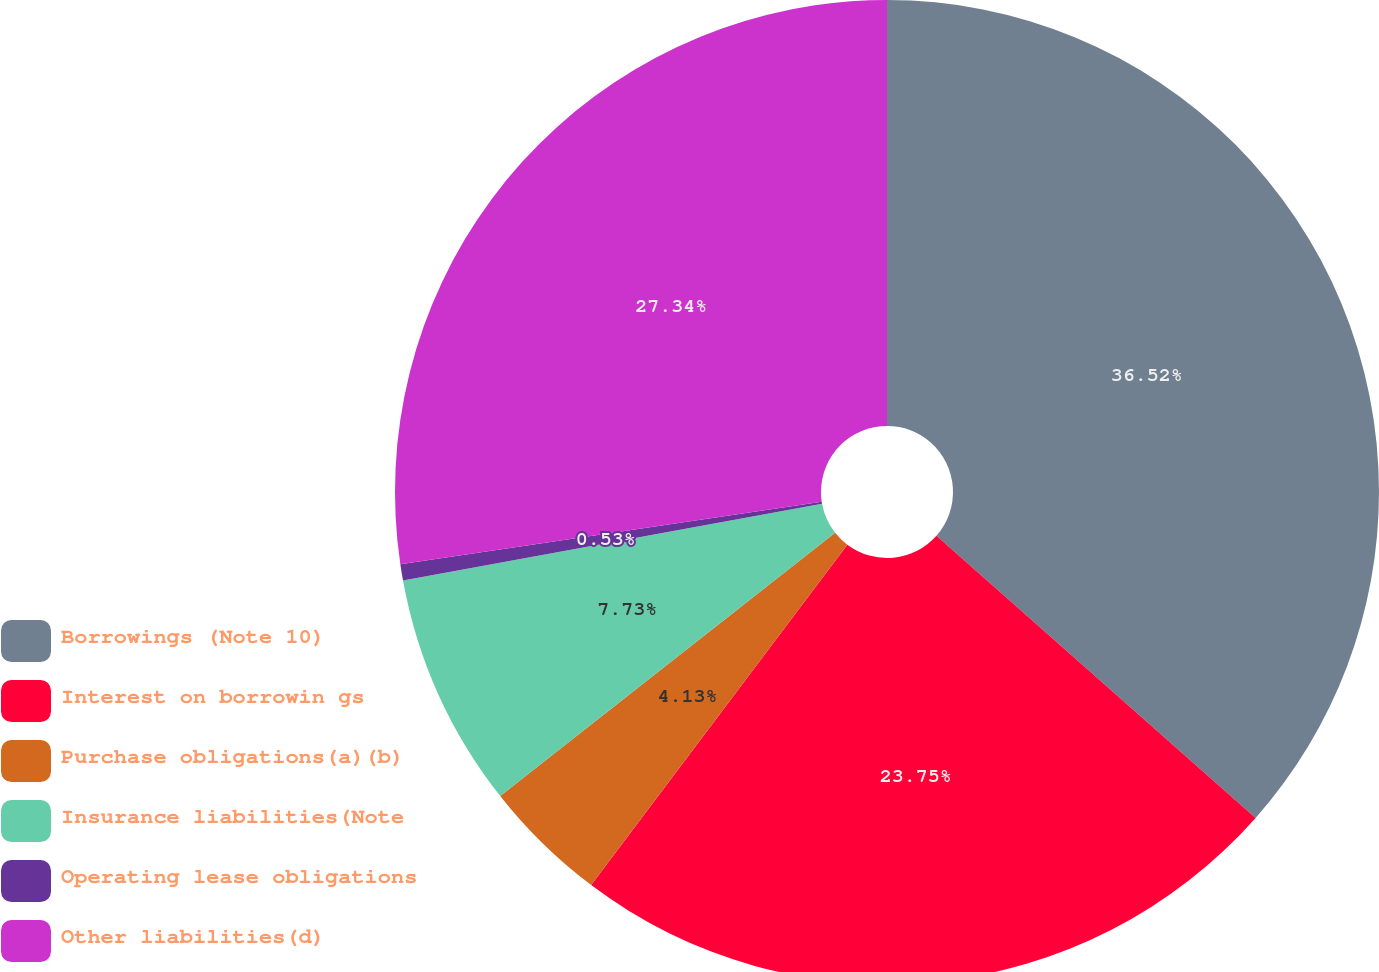<chart> <loc_0><loc_0><loc_500><loc_500><pie_chart><fcel>Borrowings (Note 10)<fcel>Interest on borrowin gs<fcel>Purchase obligations(a)(b)<fcel>Insurance liabilities(Note<fcel>Operating lease obligations<fcel>Other liabilities(d)<nl><fcel>36.53%<fcel>23.75%<fcel>4.13%<fcel>7.73%<fcel>0.53%<fcel>27.35%<nl></chart> 